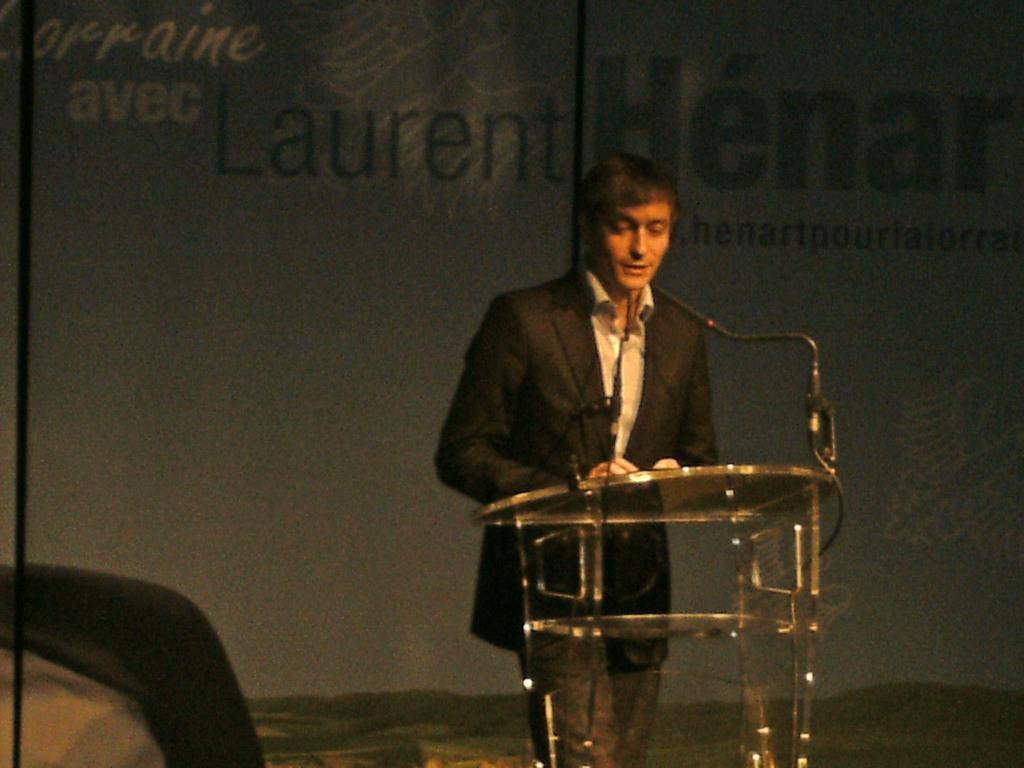Who or what is the main subject in the image? There is a person in the image. What can be observed about the person's attire? The person is wearing clothes. Where is the person located in the image? The person is standing in front of a podium. What is written or depicted at the top of the image? There is text at the top of the image. How many toys can be seen on the ground near the person in the image? There are no toys present in the image. What type of boundary is visible in the image? There is no boundary visible in the image. 